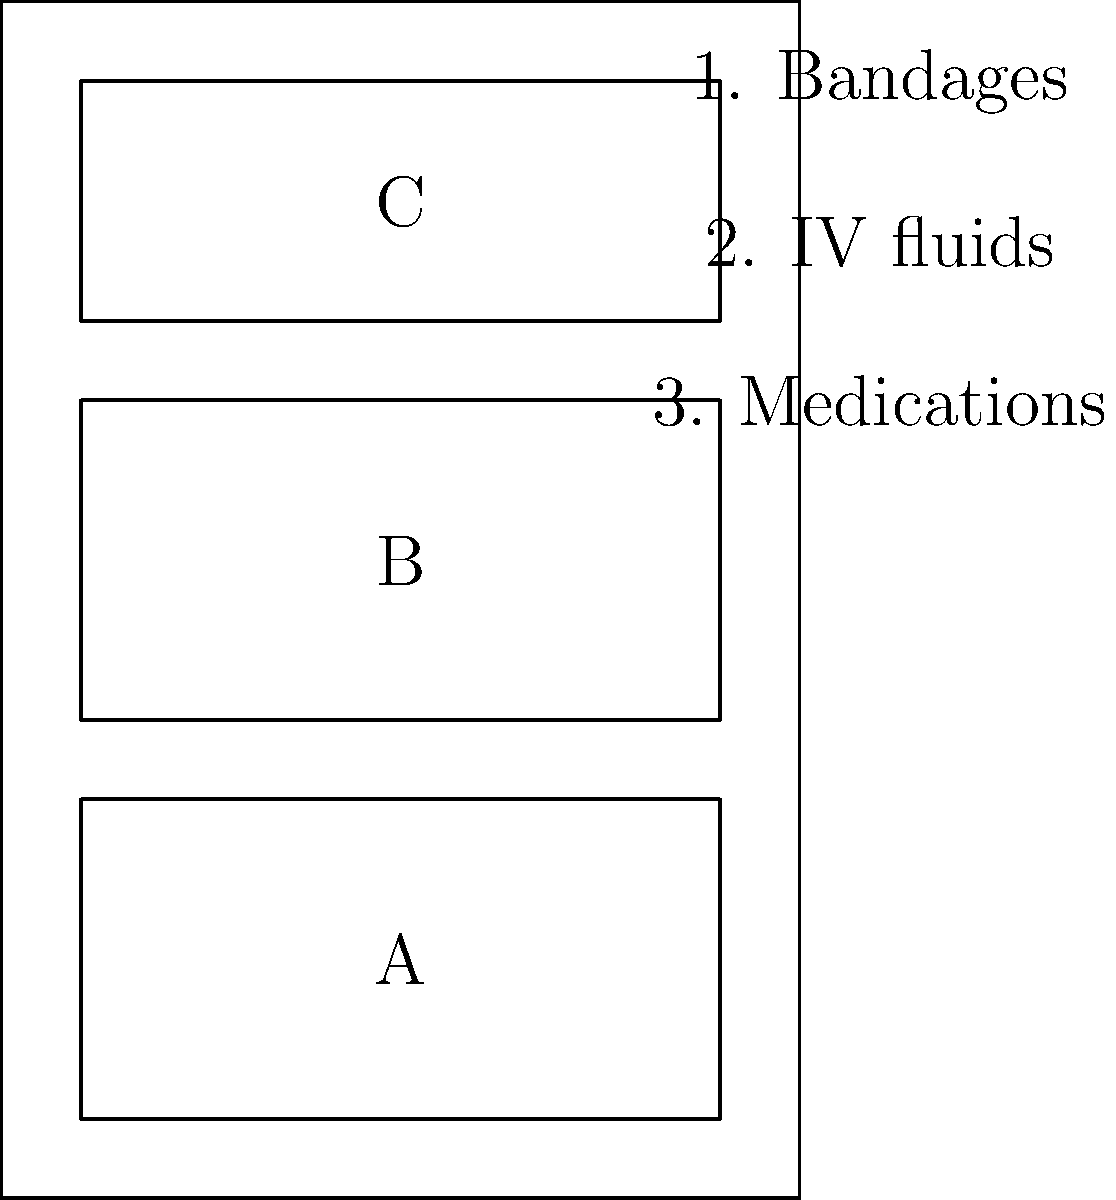In a standard-issue military medical backpack, which compartment (A, B, or C) would be most suitable for storing IV fluids to ensure quick access and prevent damage during transport? To determine the most suitable compartment for storing IV fluids in a military medical backpack, we need to consider several factors:

1. Quick access: IV fluids are often needed urgently in emergency situations, so they should be easily accessible.
2. Protection: IV fluids are typically stored in bags or bottles that can be damaged if not properly secured.
3. Weight distribution: Heavier items should be placed closer to the wearer's back for better balance.

Analyzing the compartments:

A. Bottom compartment: This is closest to the wearer's back, making it ideal for heavier items. However, it may be difficult to access quickly in emergencies.
B. Middle compartment: This offers a balance between accessibility and protection. It's not too low to hinder quick access but still provides some cushioning from external impacts.
C. Top compartment: While easily accessible, this compartment is more susceptible to external pressure and impacts, which could damage the IV fluid bags.

Considering these factors, the middle compartment (B) would be the most suitable for storing IV fluids. It provides:

1. Reasonable accessibility for emergency situations
2. Better protection than the top compartment
3. Proper weight distribution, as it's not at the very bottom of the backpack

This arrangement allows for quick access to IV fluids while maintaining the integrity of the supplies and ensuring proper weight distribution in the backpack.
Answer: B 